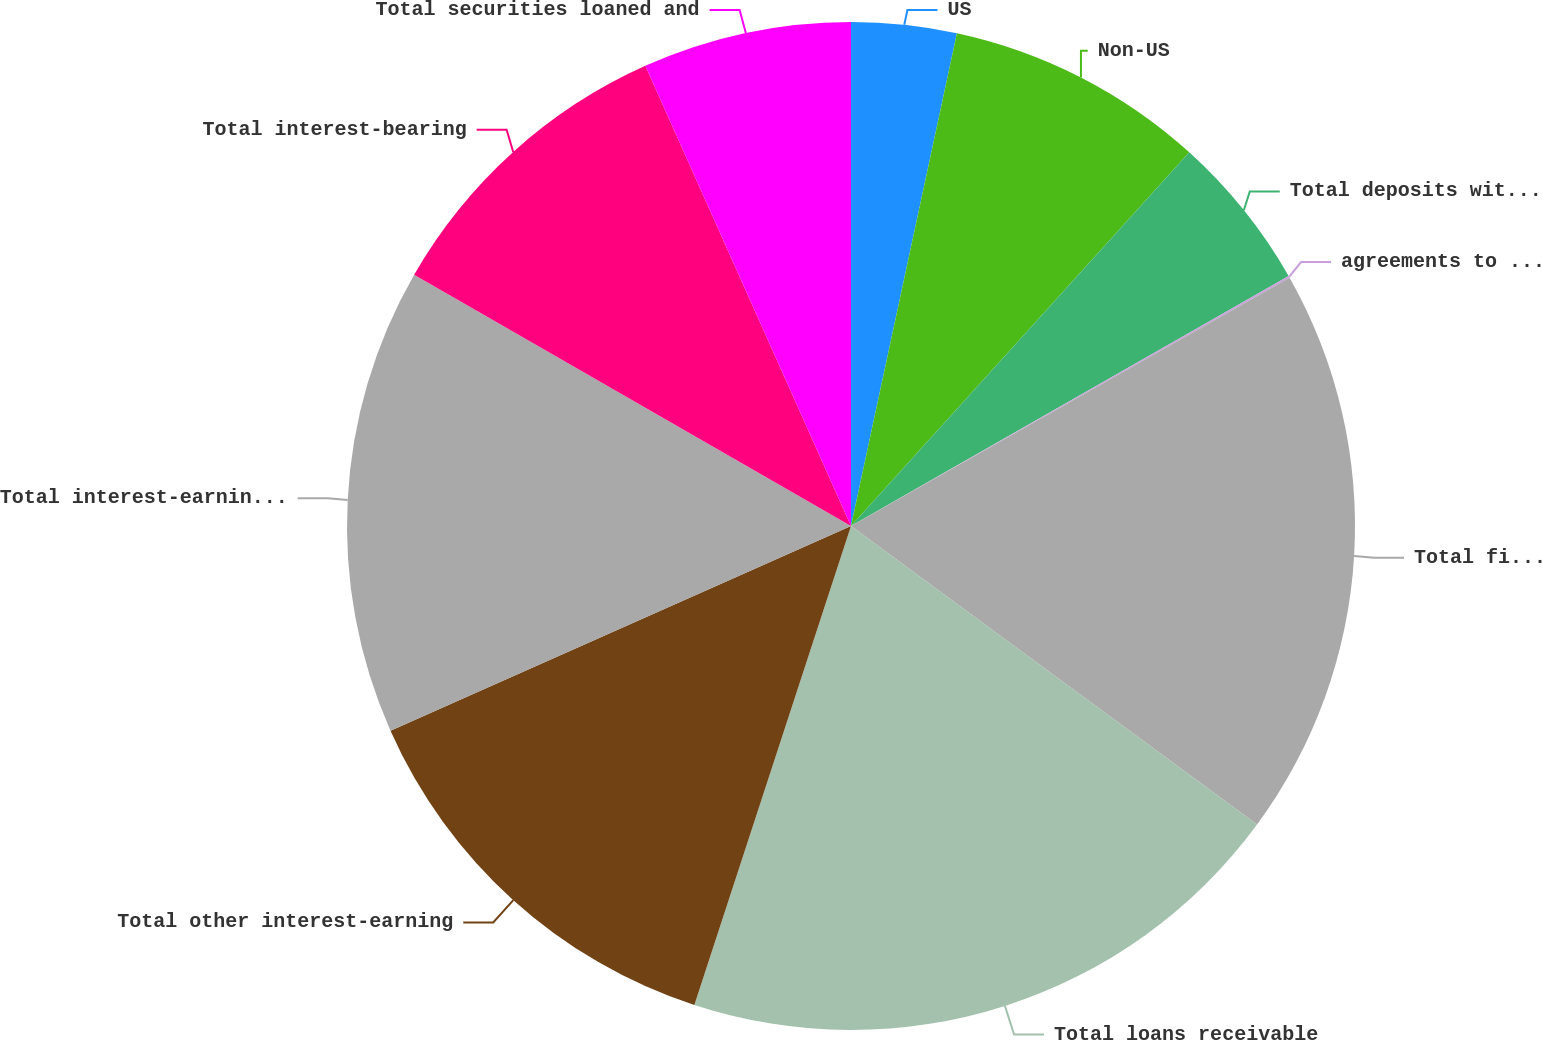<chart> <loc_0><loc_0><loc_500><loc_500><pie_chart><fcel>US<fcel>Non-US<fcel>Total deposits with banks<fcel>agreements to resell and<fcel>Total financial instruments<fcel>Total loans receivable<fcel>Total other interest-earning<fcel>Total interest-earning assets<fcel>Total interest-bearing<fcel>Total securities loaned and<nl><fcel>3.37%<fcel>8.34%<fcel>5.03%<fcel>0.06%<fcel>18.29%<fcel>19.94%<fcel>13.31%<fcel>14.97%<fcel>10.0%<fcel>6.69%<nl></chart> 